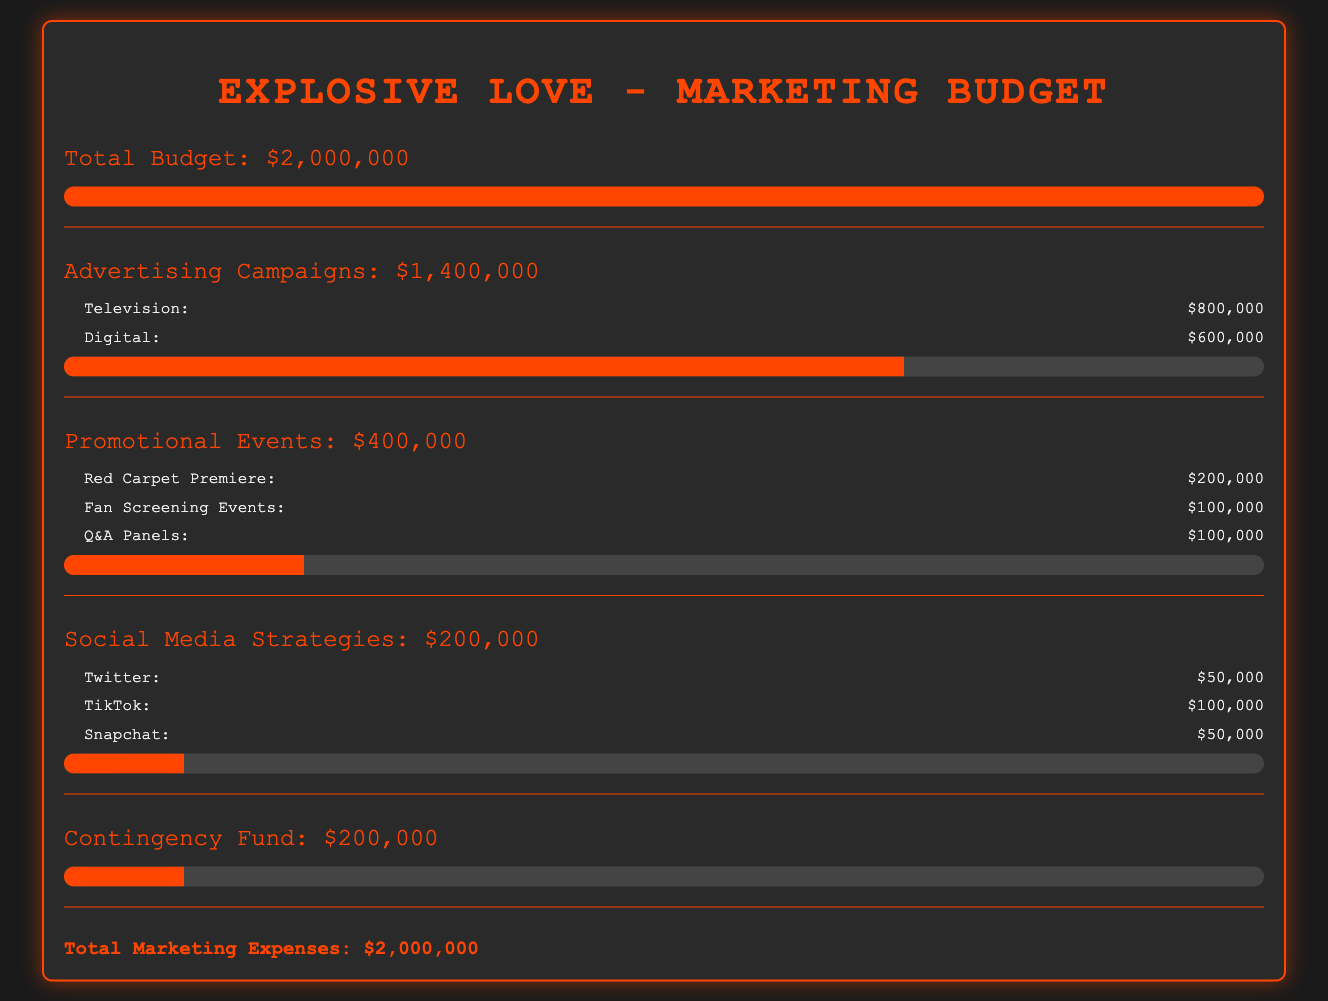What is the total marketing budget? The total budget listed in the document is for the marketing expenses of the film, which is $2,000,000.
Answer: $2,000,000 How much is allocated for advertising campaigns? The document specifies that the advertising campaigns have a budget of $1,400,000.
Answer: $1,400,000 What is the cost for the Red Carpet Premiere? The document details that the cost for the Red Carpet Premiere is $200,000.
Answer: $200,000 How much is spent on TikTok for social media strategies? According to the document, TikTok's budget is $100,000.
Answer: $100,000 What percentage of the budget is allocated to social media strategies? The document indicates that social media strategies account for $200,000 out of the total budget of $2,000,000, which is 10%.
Answer: 10% What is the total amount for promotional events? The document outlines that promotional events total $400,000.
Answer: $400,000 What is the contingency fund amount? The document specifies that the contingency fund is set at $200,000.
Answer: $200,000 Which advertising campaign has the highest allocation? The document states that the television advertising campaign has the highest allocation of $800,000.
Answer: Television How many fan screening events are budgeted? The document lists the fan screening events budget as $100,000.
Answer: $100,000 What is the total for digital advertising? The document details that digital advertising expenditures are $600,000.
Answer: $600,000 